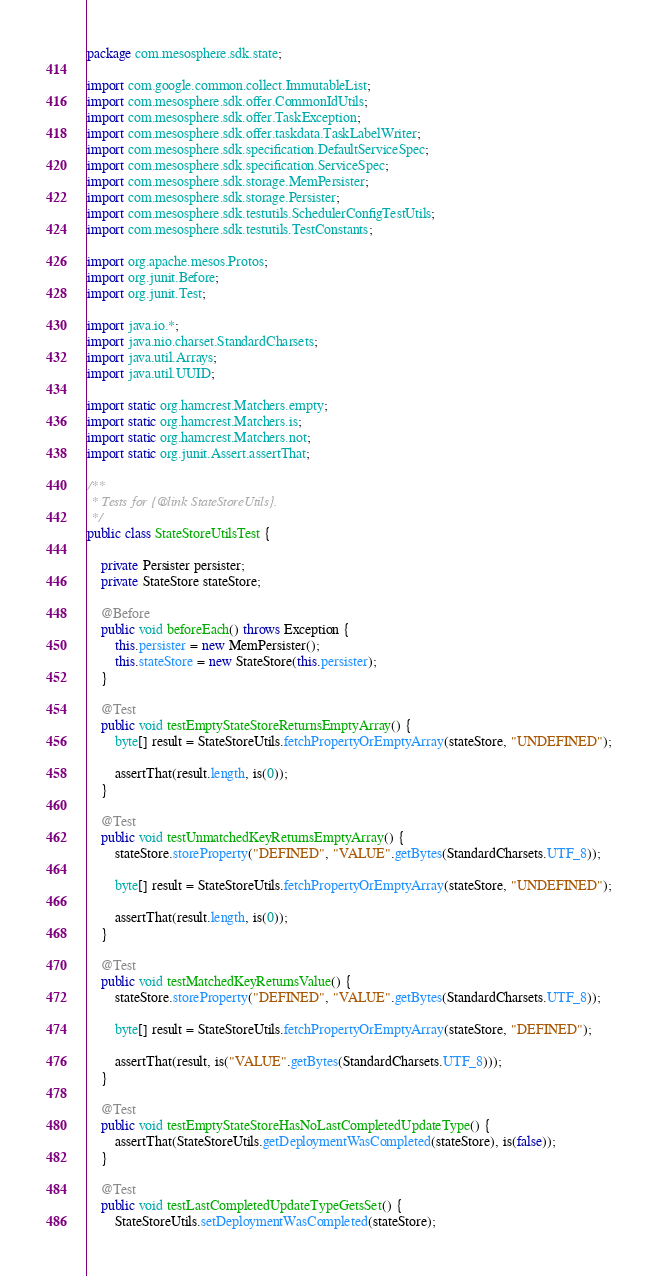Convert code to text. <code><loc_0><loc_0><loc_500><loc_500><_Java_>package com.mesosphere.sdk.state;

import com.google.common.collect.ImmutableList;
import com.mesosphere.sdk.offer.CommonIdUtils;
import com.mesosphere.sdk.offer.TaskException;
import com.mesosphere.sdk.offer.taskdata.TaskLabelWriter;
import com.mesosphere.sdk.specification.DefaultServiceSpec;
import com.mesosphere.sdk.specification.ServiceSpec;
import com.mesosphere.sdk.storage.MemPersister;
import com.mesosphere.sdk.storage.Persister;
import com.mesosphere.sdk.testutils.SchedulerConfigTestUtils;
import com.mesosphere.sdk.testutils.TestConstants;

import org.apache.mesos.Protos;
import org.junit.Before;
import org.junit.Test;

import java.io.*;
import java.nio.charset.StandardCharsets;
import java.util.Arrays;
import java.util.UUID;

import static org.hamcrest.Matchers.empty;
import static org.hamcrest.Matchers.is;
import static org.hamcrest.Matchers.not;
import static org.junit.Assert.assertThat;

/**
 * Tests for {@link StateStoreUtils}.
 */
public class StateStoreUtilsTest {

    private Persister persister;
    private StateStore stateStore;

    @Before
    public void beforeEach() throws Exception {
        this.persister = new MemPersister();
        this.stateStore = new StateStore(this.persister);
    }

    @Test
    public void testEmptyStateStoreReturnsEmptyArray() {
        byte[] result = StateStoreUtils.fetchPropertyOrEmptyArray(stateStore, "UNDEFINED");

        assertThat(result.length, is(0));
    }

    @Test
    public void testUnmatchedKeyReturnsEmptyArray() {
        stateStore.storeProperty("DEFINED", "VALUE".getBytes(StandardCharsets.UTF_8));

        byte[] result = StateStoreUtils.fetchPropertyOrEmptyArray(stateStore, "UNDEFINED");

        assertThat(result.length, is(0));
    }

    @Test
    public void testMatchedKeyReturnsValue() {
        stateStore.storeProperty("DEFINED", "VALUE".getBytes(StandardCharsets.UTF_8));

        byte[] result = StateStoreUtils.fetchPropertyOrEmptyArray(stateStore, "DEFINED");

        assertThat(result, is("VALUE".getBytes(StandardCharsets.UTF_8)));
    }

    @Test
    public void testEmptyStateStoreHasNoLastCompletedUpdateType() {
        assertThat(StateStoreUtils.getDeploymentWasCompleted(stateStore), is(false));
    }

    @Test
    public void testLastCompletedUpdateTypeGetsSet() {
        StateStoreUtils.setDeploymentWasCompleted(stateStore);</code> 